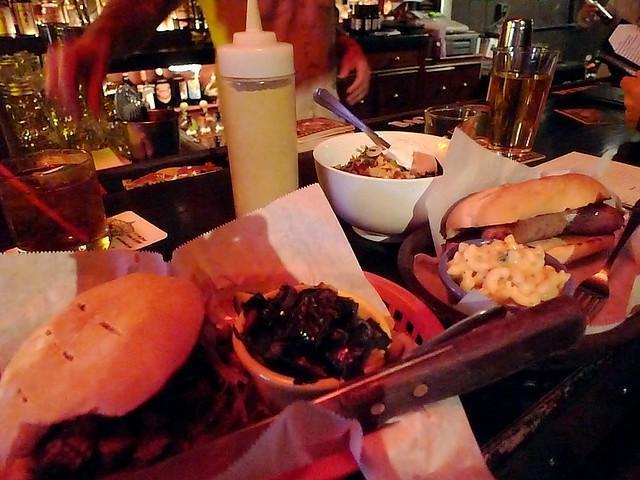Verify the accuracy of this image caption: "The sandwich is at the side of the dining table.".
Answer yes or no. Yes. 